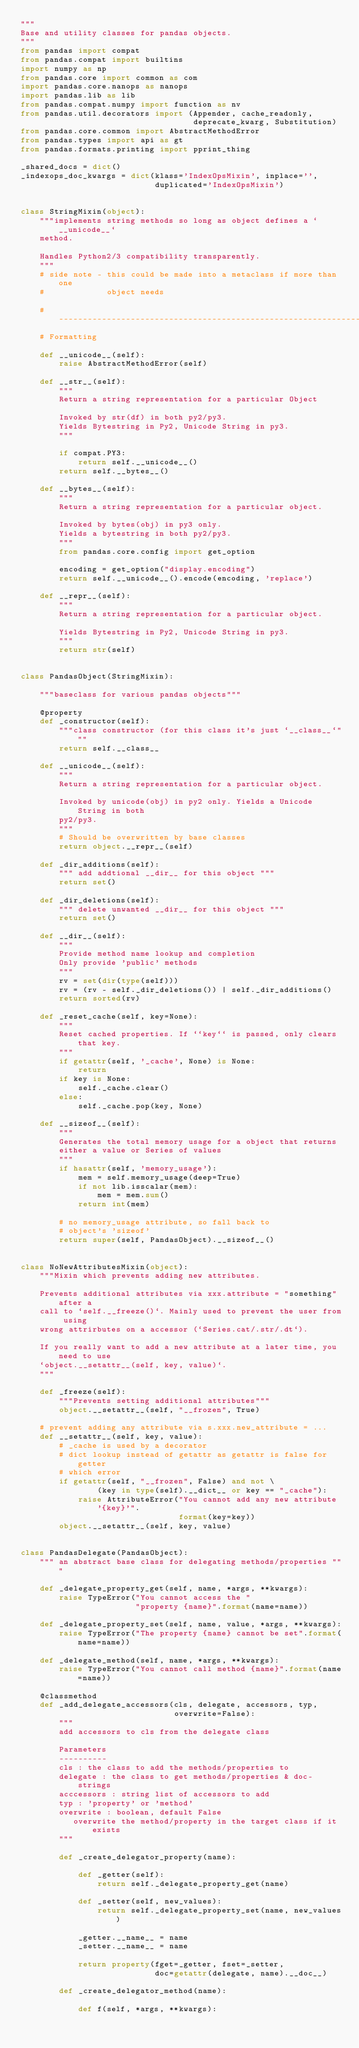Convert code to text. <code><loc_0><loc_0><loc_500><loc_500><_Python_>"""
Base and utility classes for pandas objects.
"""
from pandas import compat
from pandas.compat import builtins
import numpy as np
from pandas.core import common as com
import pandas.core.nanops as nanops
import pandas.lib as lib
from pandas.compat.numpy import function as nv
from pandas.util.decorators import (Appender, cache_readonly,
                                    deprecate_kwarg, Substitution)
from pandas.core.common import AbstractMethodError
from pandas.types import api as gt
from pandas.formats.printing import pprint_thing

_shared_docs = dict()
_indexops_doc_kwargs = dict(klass='IndexOpsMixin', inplace='',
                            duplicated='IndexOpsMixin')


class StringMixin(object):
    """implements string methods so long as object defines a `__unicode__`
    method.

    Handles Python2/3 compatibility transparently.
    """
    # side note - this could be made into a metaclass if more than one
    #             object needs

    # ----------------------------------------------------------------------
    # Formatting

    def __unicode__(self):
        raise AbstractMethodError(self)

    def __str__(self):
        """
        Return a string representation for a particular Object

        Invoked by str(df) in both py2/py3.
        Yields Bytestring in Py2, Unicode String in py3.
        """

        if compat.PY3:
            return self.__unicode__()
        return self.__bytes__()

    def __bytes__(self):
        """
        Return a string representation for a particular object.

        Invoked by bytes(obj) in py3 only.
        Yields a bytestring in both py2/py3.
        """
        from pandas.core.config import get_option

        encoding = get_option("display.encoding")
        return self.__unicode__().encode(encoding, 'replace')

    def __repr__(self):
        """
        Return a string representation for a particular object.

        Yields Bytestring in Py2, Unicode String in py3.
        """
        return str(self)


class PandasObject(StringMixin):

    """baseclass for various pandas objects"""

    @property
    def _constructor(self):
        """class constructor (for this class it's just `__class__`"""
        return self.__class__

    def __unicode__(self):
        """
        Return a string representation for a particular object.

        Invoked by unicode(obj) in py2 only. Yields a Unicode String in both
        py2/py3.
        """
        # Should be overwritten by base classes
        return object.__repr__(self)

    def _dir_additions(self):
        """ add addtional __dir__ for this object """
        return set()

    def _dir_deletions(self):
        """ delete unwanted __dir__ for this object """
        return set()

    def __dir__(self):
        """
        Provide method name lookup and completion
        Only provide 'public' methods
        """
        rv = set(dir(type(self)))
        rv = (rv - self._dir_deletions()) | self._dir_additions()
        return sorted(rv)

    def _reset_cache(self, key=None):
        """
        Reset cached properties. If ``key`` is passed, only clears that key.
        """
        if getattr(self, '_cache', None) is None:
            return
        if key is None:
            self._cache.clear()
        else:
            self._cache.pop(key, None)

    def __sizeof__(self):
        """
        Generates the total memory usage for a object that returns
        either a value or Series of values
        """
        if hasattr(self, 'memory_usage'):
            mem = self.memory_usage(deep=True)
            if not lib.isscalar(mem):
                mem = mem.sum()
            return int(mem)

        # no memory_usage attribute, so fall back to
        # object's 'sizeof'
        return super(self, PandasObject).__sizeof__()


class NoNewAttributesMixin(object):
    """Mixin which prevents adding new attributes.

    Prevents additional attributes via xxx.attribute = "something" after a
    call to `self.__freeze()`. Mainly used to prevent the user from using
    wrong attrirbutes on a accessor (`Series.cat/.str/.dt`).

    If you really want to add a new attribute at a later time, you need to use
    `object.__setattr__(self, key, value)`.
    """

    def _freeze(self):
        """Prevents setting additional attributes"""
        object.__setattr__(self, "__frozen", True)

    # prevent adding any attribute via s.xxx.new_attribute = ...
    def __setattr__(self, key, value):
        # _cache is used by a decorator
        # dict lookup instead of getattr as getattr is false for getter
        # which error
        if getattr(self, "__frozen", False) and not \
                (key in type(self).__dict__ or key == "_cache"):
            raise AttributeError("You cannot add any new attribute '{key}'".
                                 format(key=key))
        object.__setattr__(self, key, value)


class PandasDelegate(PandasObject):
    """ an abstract base class for delegating methods/properties """

    def _delegate_property_get(self, name, *args, **kwargs):
        raise TypeError("You cannot access the "
                        "property {name}".format(name=name))

    def _delegate_property_set(self, name, value, *args, **kwargs):
        raise TypeError("The property {name} cannot be set".format(name=name))

    def _delegate_method(self, name, *args, **kwargs):
        raise TypeError("You cannot call method {name}".format(name=name))

    @classmethod
    def _add_delegate_accessors(cls, delegate, accessors, typ,
                                overwrite=False):
        """
        add accessors to cls from the delegate class

        Parameters
        ----------
        cls : the class to add the methods/properties to
        delegate : the class to get methods/properties & doc-strings
        acccessors : string list of accessors to add
        typ : 'property' or 'method'
        overwrite : boolean, default False
           overwrite the method/property in the target class if it exists
        """

        def _create_delegator_property(name):

            def _getter(self):
                return self._delegate_property_get(name)

            def _setter(self, new_values):
                return self._delegate_property_set(name, new_values)

            _getter.__name__ = name
            _setter.__name__ = name

            return property(fget=_getter, fset=_setter,
                            doc=getattr(delegate, name).__doc__)

        def _create_delegator_method(name):

            def f(self, *args, **kwargs):</code> 